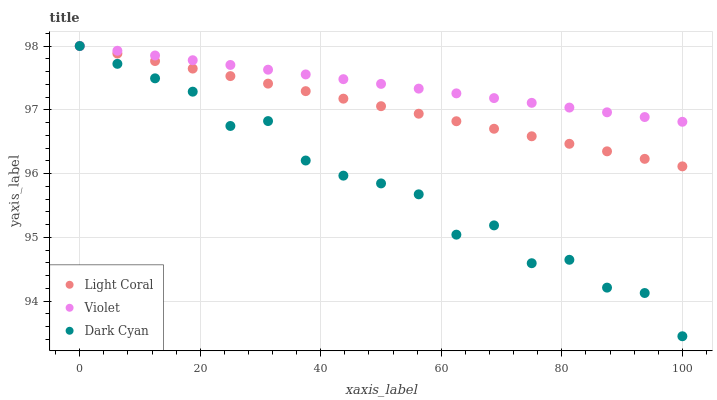Does Dark Cyan have the minimum area under the curve?
Answer yes or no. Yes. Does Violet have the maximum area under the curve?
Answer yes or no. Yes. Does Violet have the minimum area under the curve?
Answer yes or no. No. Does Dark Cyan have the maximum area under the curve?
Answer yes or no. No. Is Light Coral the smoothest?
Answer yes or no. Yes. Is Dark Cyan the roughest?
Answer yes or no. Yes. Is Violet the smoothest?
Answer yes or no. No. Is Violet the roughest?
Answer yes or no. No. Does Dark Cyan have the lowest value?
Answer yes or no. Yes. Does Violet have the lowest value?
Answer yes or no. No. Does Violet have the highest value?
Answer yes or no. Yes. Does Light Coral intersect Violet?
Answer yes or no. Yes. Is Light Coral less than Violet?
Answer yes or no. No. Is Light Coral greater than Violet?
Answer yes or no. No. 